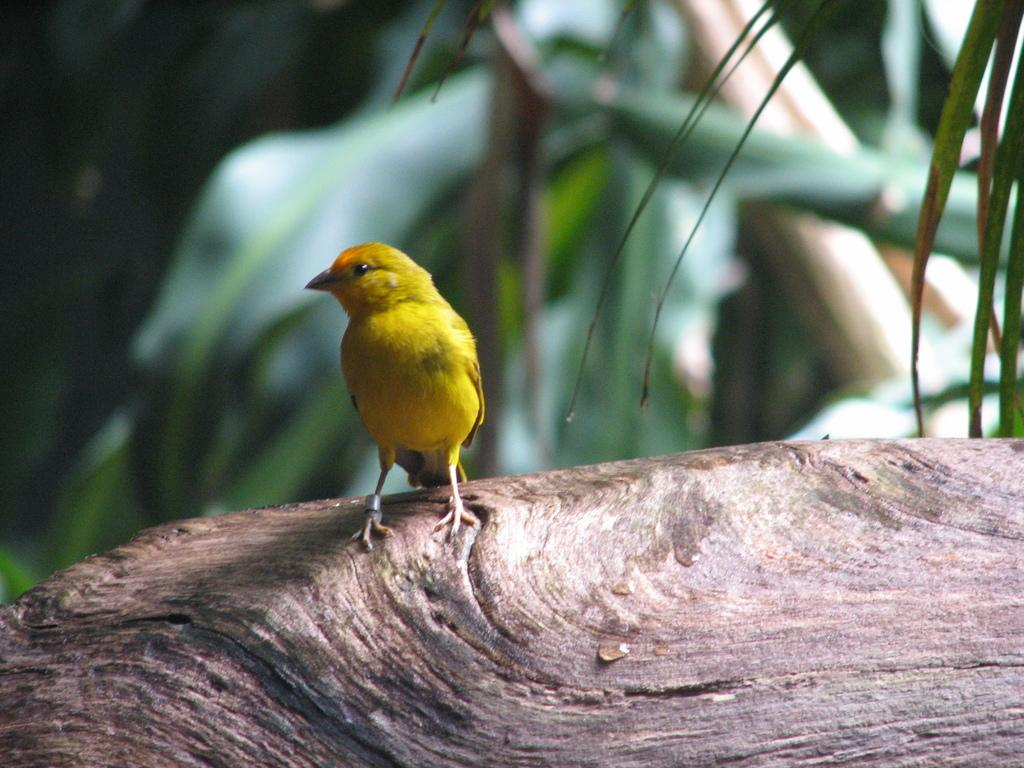What type of animal can be seen in the image? There is a bird in the image. Where is the bird located? The bird is on a tree. What else can be seen in the background of the image? There are trees visible in the background of the image. What type of cart is visible in the image? There is no cart present in the image; it features a bird on a tree and trees in the background. 